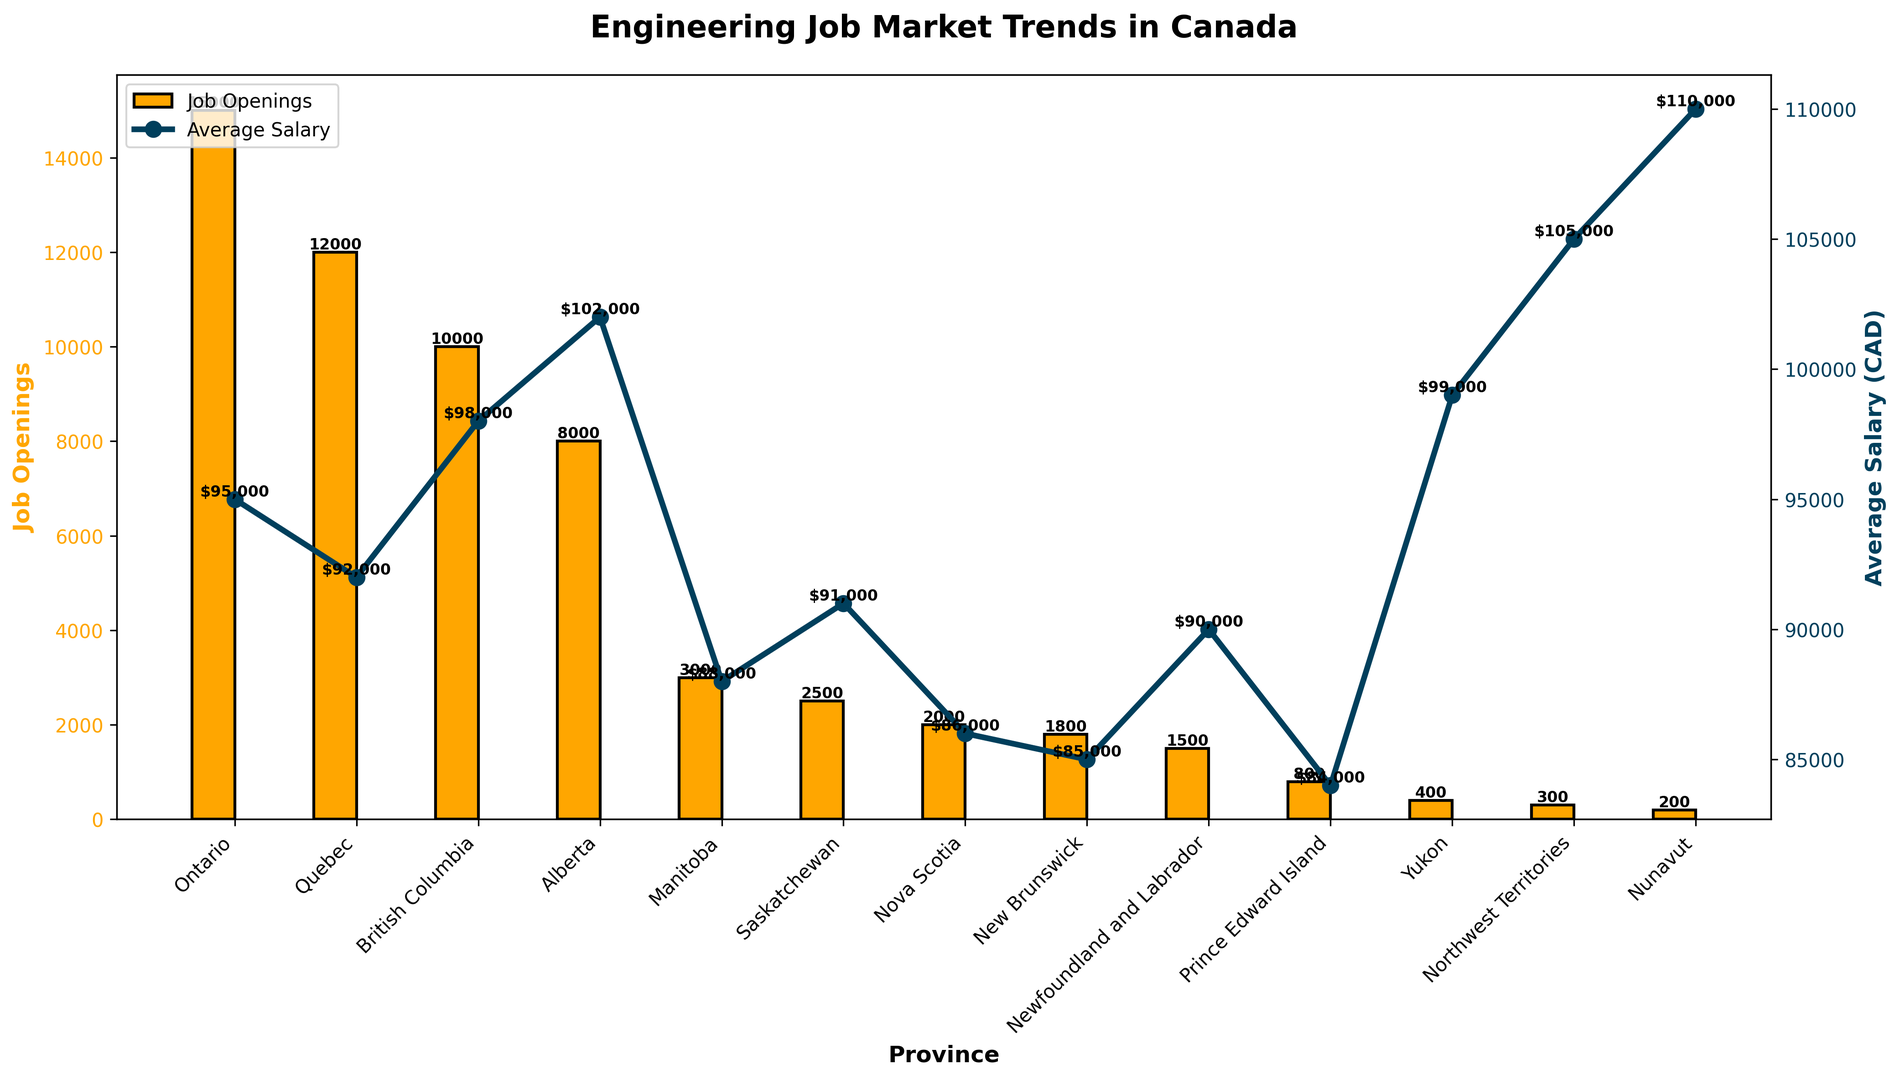Which province has the highest average salary for engineering jobs? Look at the line graph for the province with the highest point. Nunavut has the highest point at CAD 110,000.
Answer: Nunavut Which province has the most job openings for engineering roles? Check the bar heights for each province. Ontario has the tallest bar representing 15,000 job openings.
Answer: Ontario What is the difference in average salary between Alberta and Nunavut? Look at the points for Alberta and Nunavut. Alberta's salary is 102,000 CAD, and Nunavut's salary is 110,000 CAD. The difference is 110,000 - 102,000 = 8,000 CAD.
Answer: 8,000 CAD What is the average number of job openings in the four provinces with the fewest job openings? The provinces with the fewest openings are Yukon, Northwest Territories, Nunavut, and Prince Edward Island with 400, 300, 200, and 800 respectively. The average is (400 + 300 + 200 + 800) / 4 = 425.
Answer: 425 Which province has a lower average salary compared to its neighbor, Manitoba or Saskatchewan? Check the line graph for Manitoba and Saskatchewan. Manitoba's average salary is 88,000 CAD and Saskatchewan's average salary is 91,000 CAD. Manitoba has a lower salary.
Answer: Manitoba Between British Columbia and Alberta, which province has more job openings and by how much? Compare the height of the bars for both provinces. British Columbia has 10,000 and Alberta has 8,000 job openings. The difference is 10,000 - 8,000 = 2,000.
Answer: British Columbia, 2,000 What is the combined number of job openings in Nova Scotia, New Brunswick, and Newfoundland and Labrador? Sum the values for Nova Scotia, New Brunswick, and Newfoundland and Labrador. 2,000 + 1,800 + 1,500 = 5,300.
Answer: 5,300 Which provinces have both job openings less than 3,000 and an average salary greater than 90,000 CAD? Check the bars and line graph. Yukon, Northwest Territories, and Nunavut have job openings less than 3,000 and salaries of 99,000 CAD, 105,000 CAD, and 110,000 CAD respectively.
Answer: Yukon, Northwest Territories, Nunavut By how much does the average salary in Quebec fall short of the national average salary shown in the graph? To get the national average, we sum all the average salaries and divide by 13 (number of provinces). (95,000 + 92,000 + 98,000 + 102,000 + 88,000 + 91,000 + 86,000 + 85,000 + 90,000 + 84,000 + 99,000 + 105,000 + 110,000) / 13 = 94,692.3 CAD. Quebec's average salary is 92,000 CAD. The shortfall is 94,692.3 - 92,000 = 2,692.3.
Answer: 2,692.3 CAD 